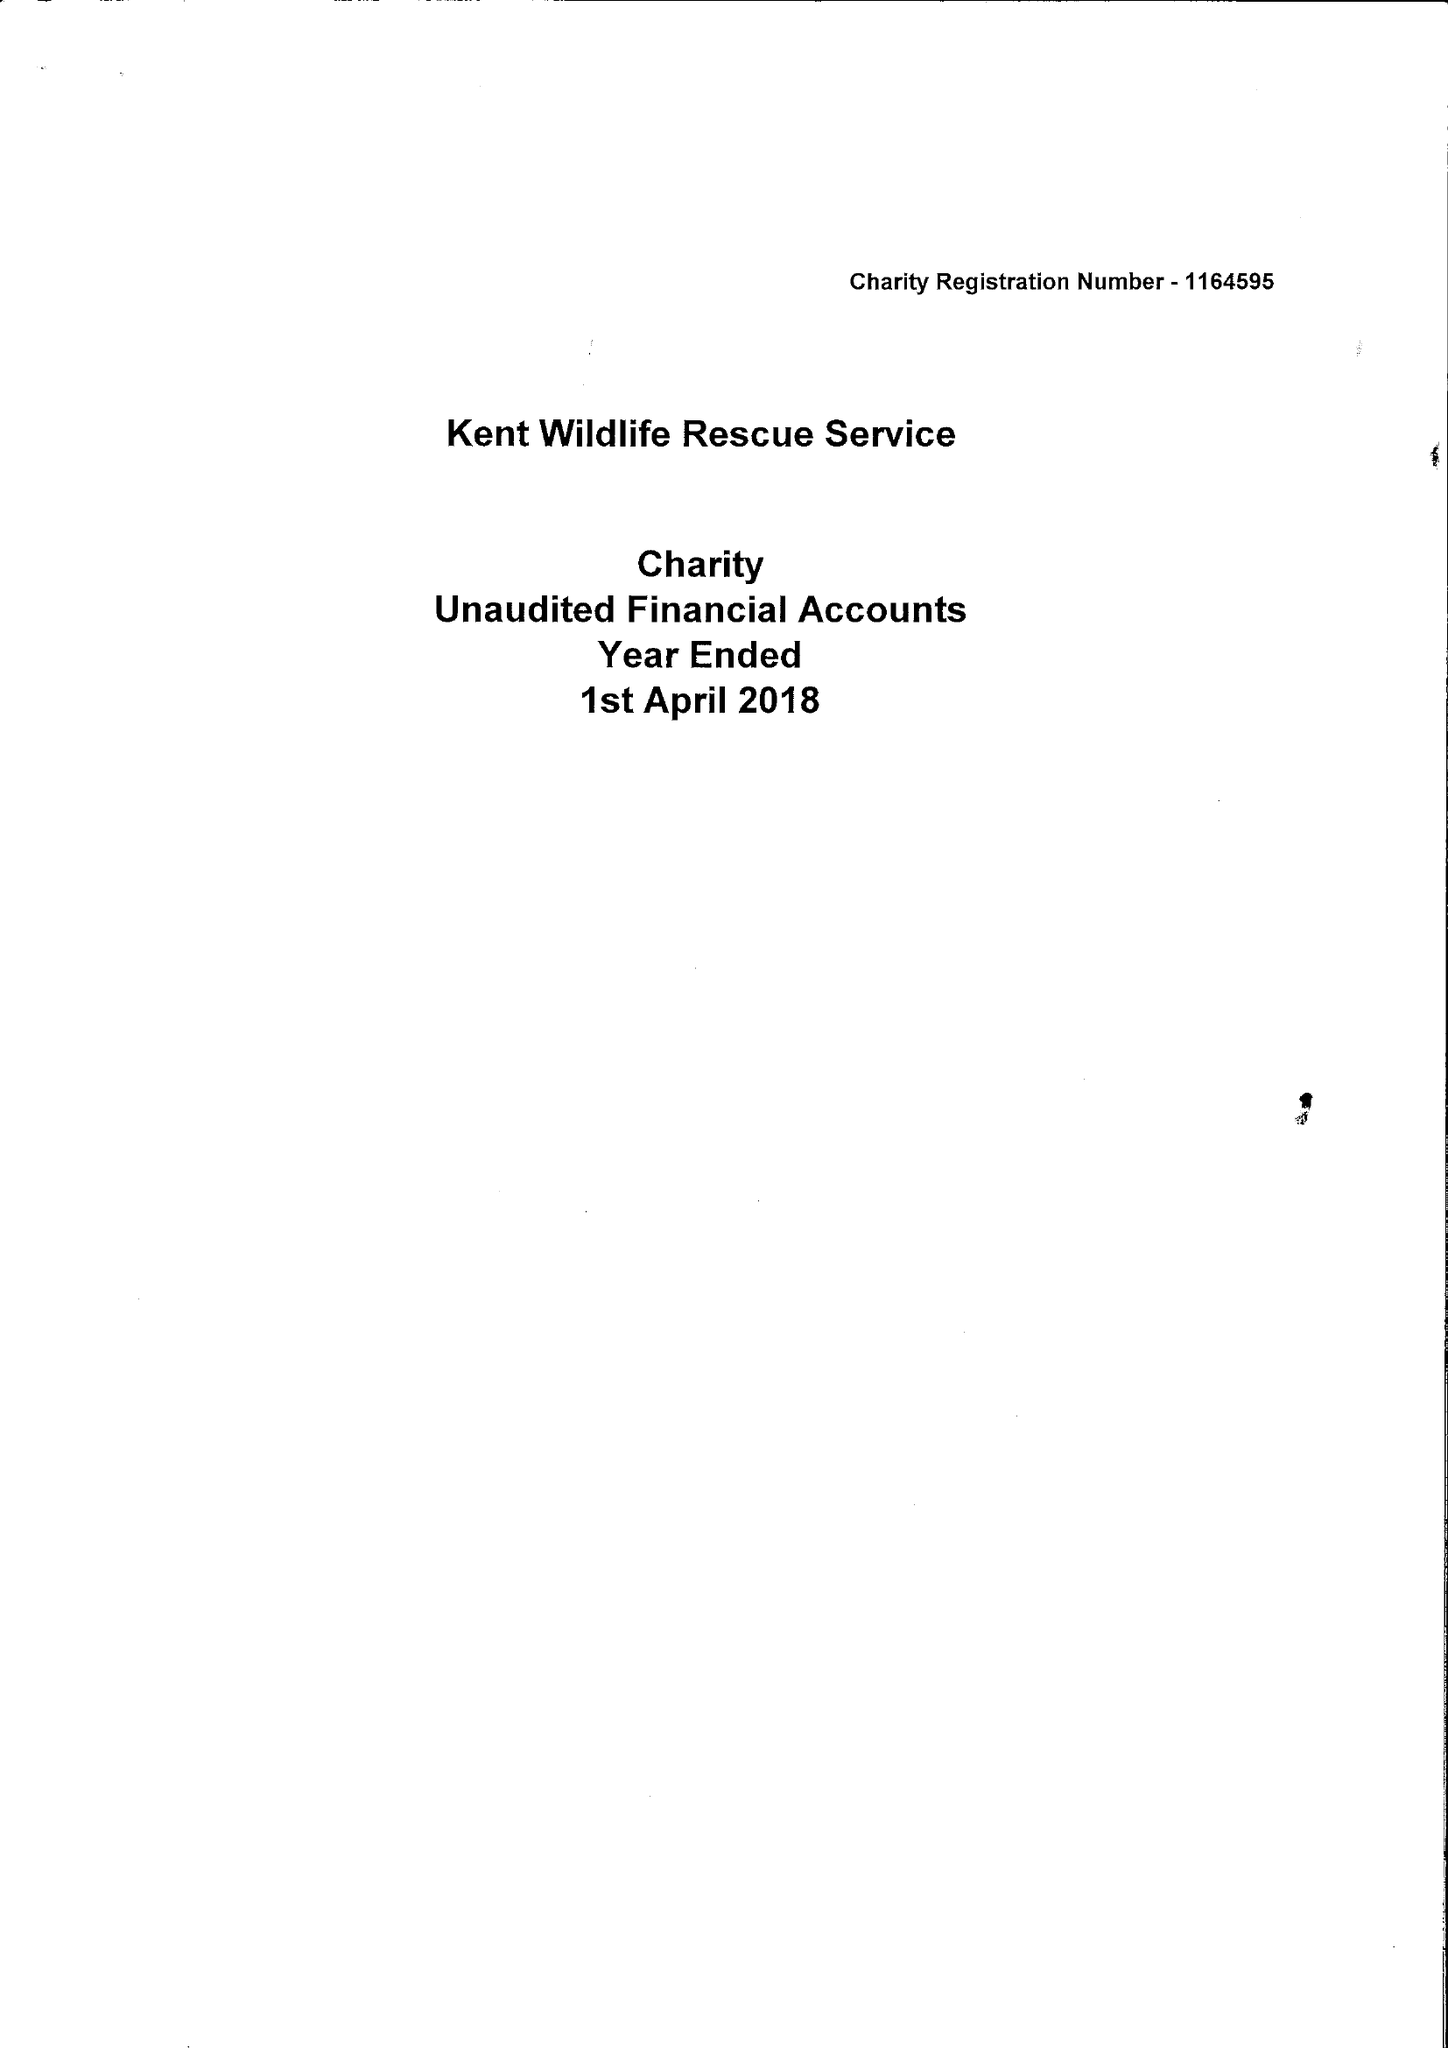What is the value for the charity_name?
Answer the question using a single word or phrase. Kent Wildlife Rescue Service 